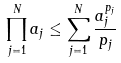Convert formula to latex. <formula><loc_0><loc_0><loc_500><loc_500>\prod _ { j = 1 } ^ { N } a _ { j } \leq \sum _ { j = 1 } ^ { N } \frac { a _ { j } ^ { p _ { j } } } { p _ { j } }</formula> 